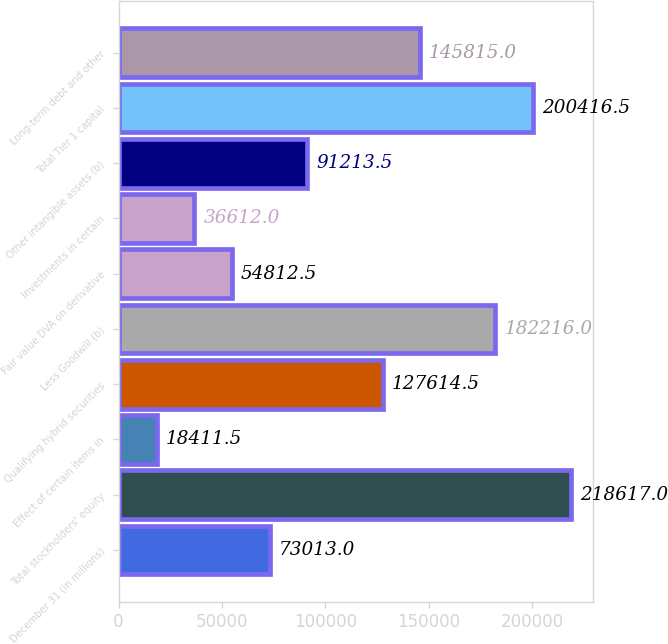Convert chart to OTSL. <chart><loc_0><loc_0><loc_500><loc_500><bar_chart><fcel>December 31 (in millions)<fcel>Total stockholders' equity<fcel>Effect of certain items in<fcel>Qualifying hybrid securities<fcel>Less Goodwill (b)<fcel>Fair value DVA on derivative<fcel>Investments in certain<fcel>Other intangible assets (b)<fcel>Total Tier 1 capital<fcel>Long-term debt and other<nl><fcel>73013<fcel>218617<fcel>18411.5<fcel>127614<fcel>182216<fcel>54812.5<fcel>36612<fcel>91213.5<fcel>200416<fcel>145815<nl></chart> 